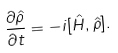<formula> <loc_0><loc_0><loc_500><loc_500>\frac { \partial \hat { \rho } } { \partial t } = - i [ \hat { H } , \hat { \rho } ] .</formula> 